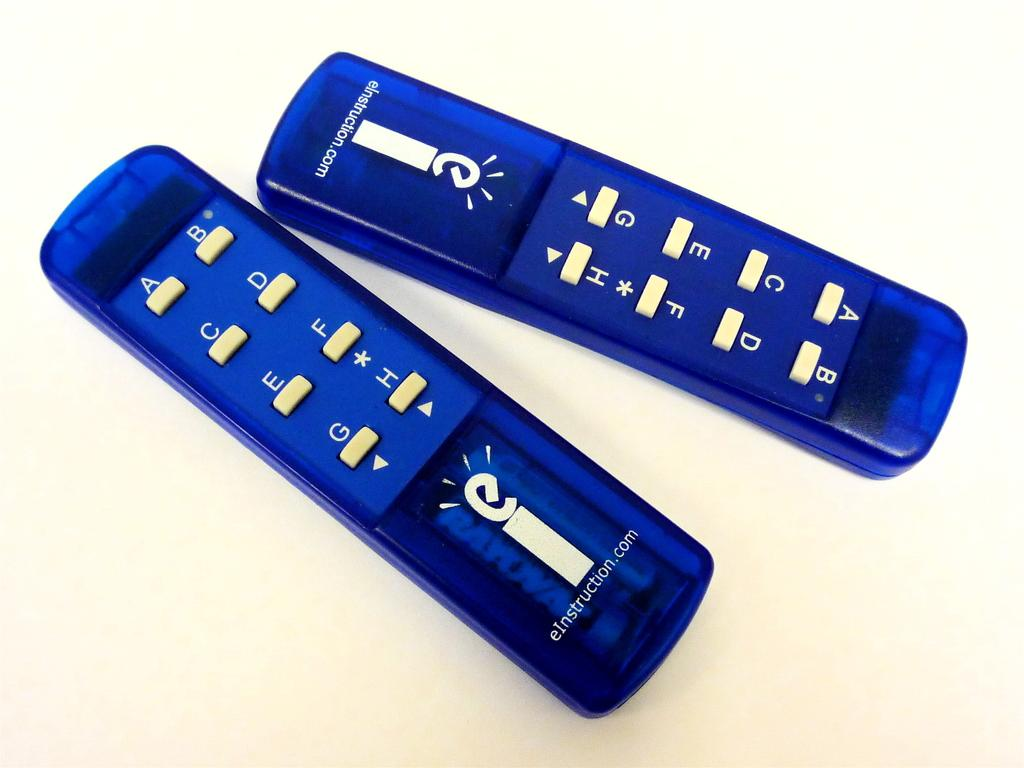<image>
Render a clear and concise summary of the photo. The blue remote is from eInstruction and is used to answer multiple choice questions in class. 